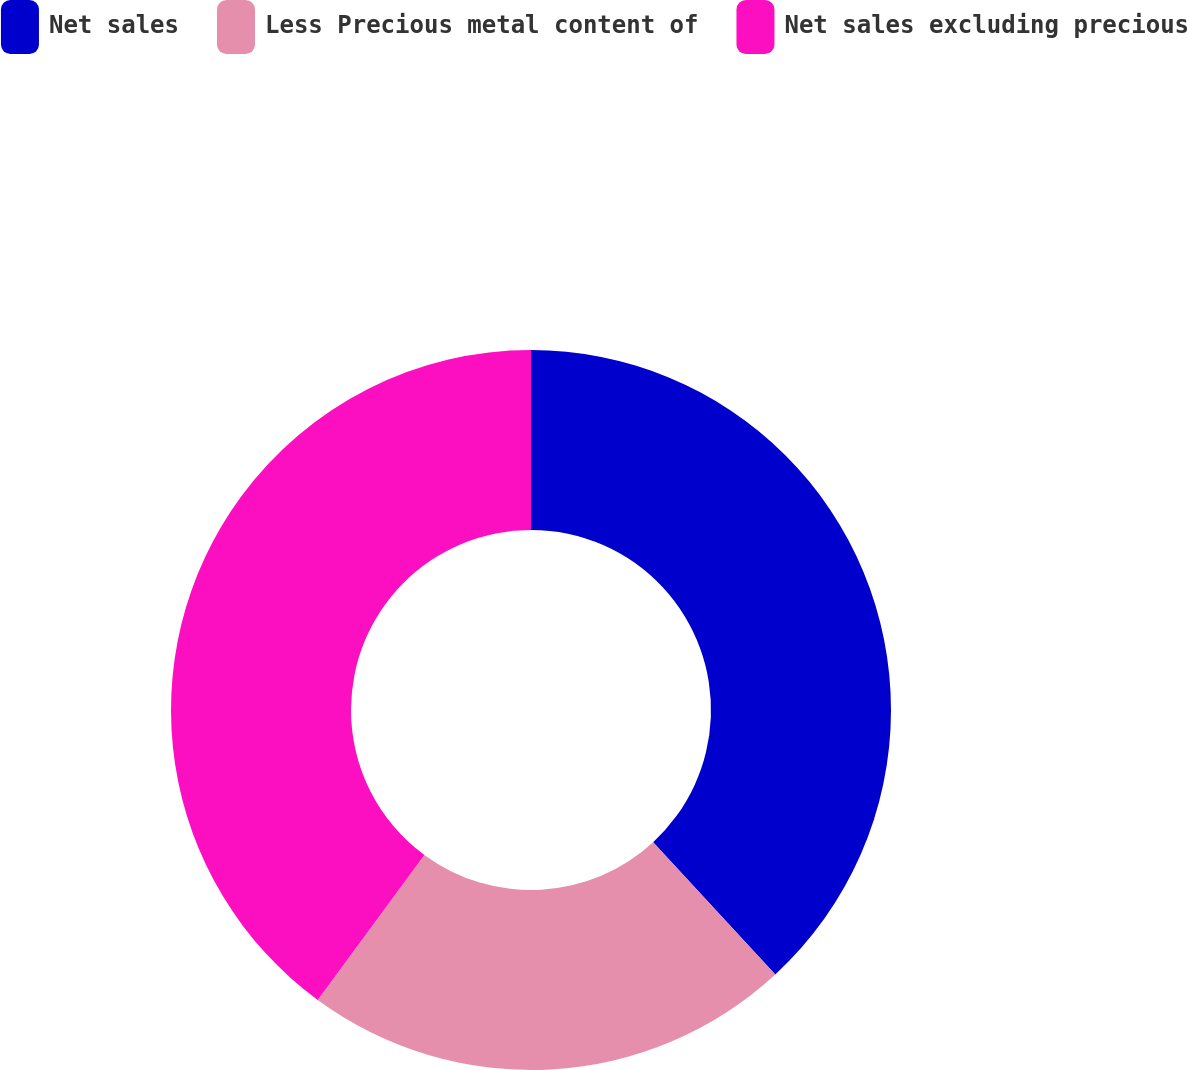Convert chart. <chart><loc_0><loc_0><loc_500><loc_500><pie_chart><fcel>Net sales<fcel>Less Precious metal content of<fcel>Net sales excluding precious<nl><fcel>38.13%<fcel>21.96%<fcel>39.91%<nl></chart> 